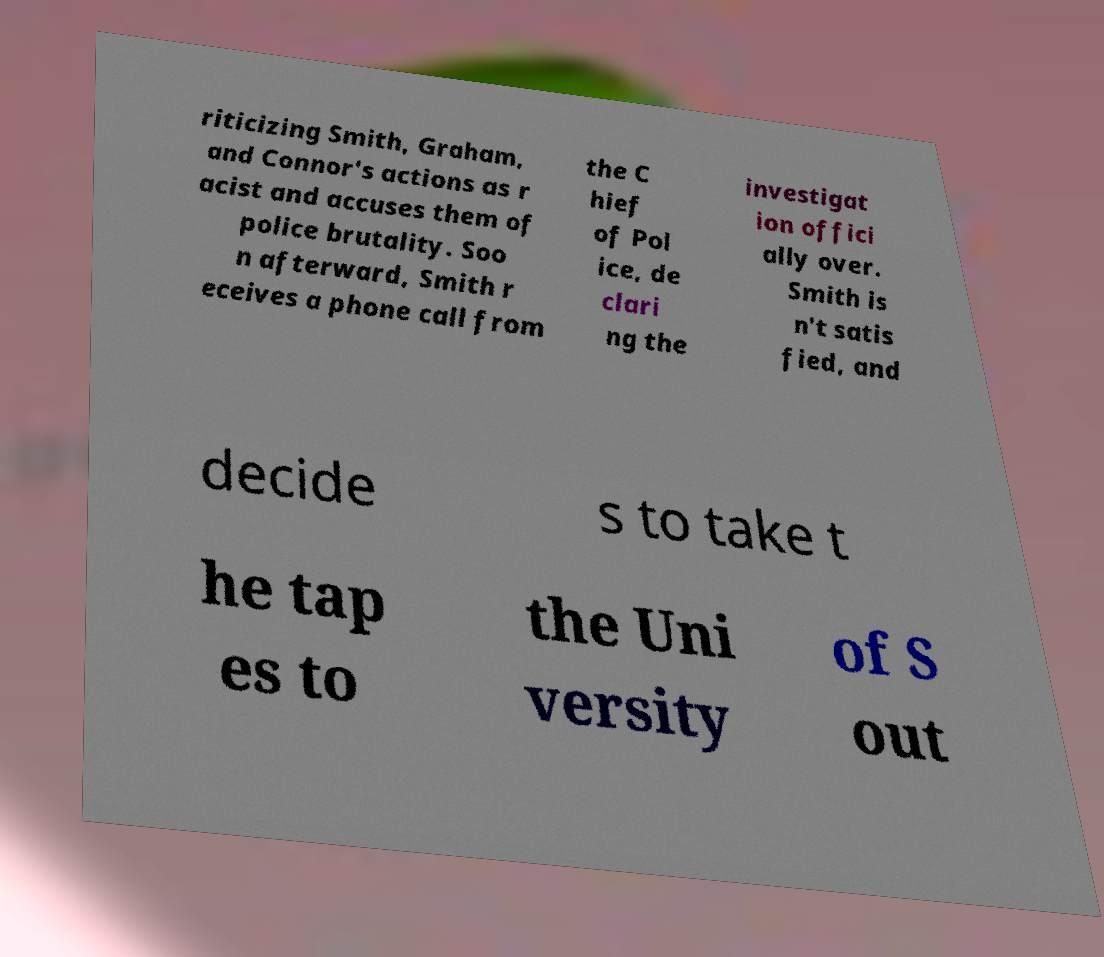Could you assist in decoding the text presented in this image and type it out clearly? riticizing Smith, Graham, and Connor's actions as r acist and accuses them of police brutality. Soo n afterward, Smith r eceives a phone call from the C hief of Pol ice, de clari ng the investigat ion offici ally over. Smith is n't satis fied, and decide s to take t he tap es to the Uni versity of S out 